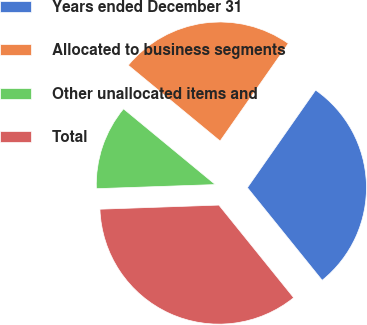<chart> <loc_0><loc_0><loc_500><loc_500><pie_chart><fcel>Years ended December 31<fcel>Allocated to business segments<fcel>Other unallocated items and<fcel>Total<nl><fcel>29.48%<fcel>23.73%<fcel>11.53%<fcel>35.26%<nl></chart> 